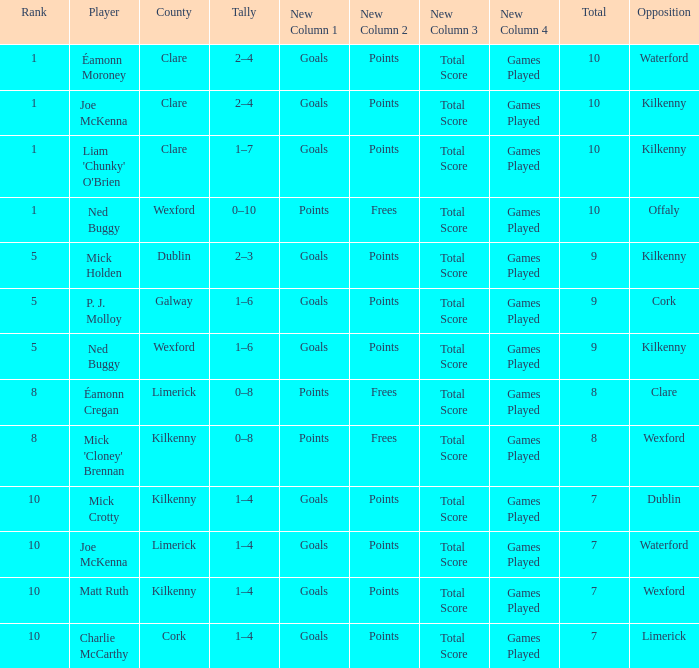What is galway county's total? 9.0. 